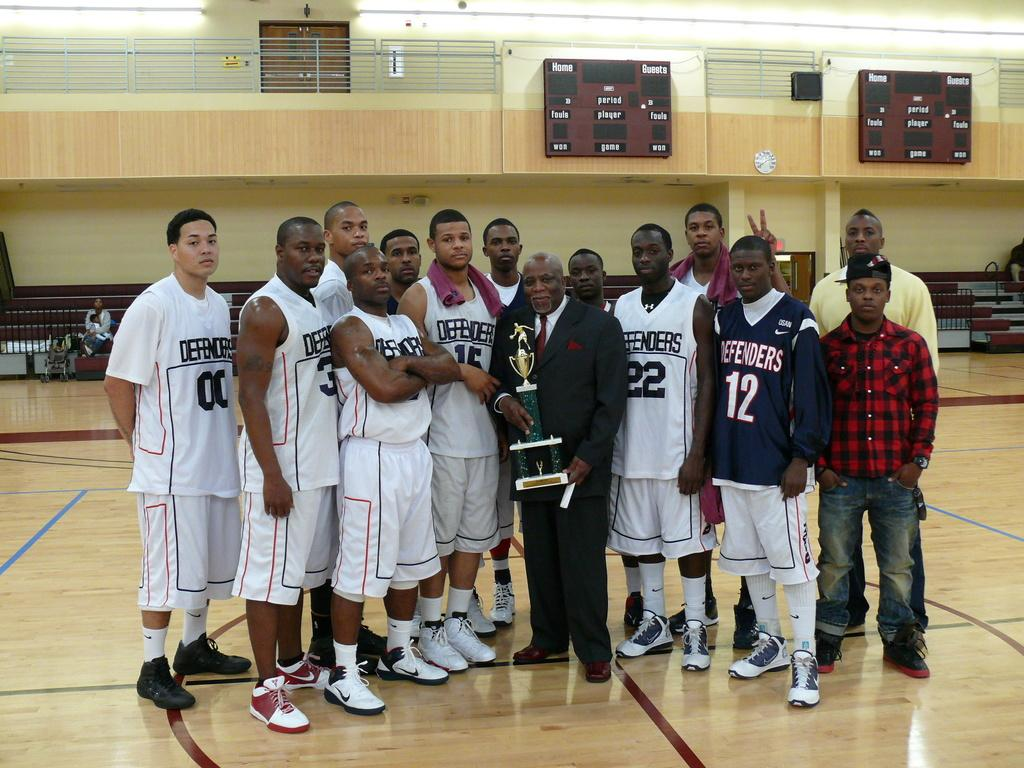What is the person in the foreground of the image holding? The person is holding a trophy in the foreground of the image. What can be seen in the center of the image? There are boys standing in the center of the image. What is visible in the background of the image? There are people, boards, a boundary, a door, and a light in the background of the image. What type of animals can be seen in the background of the image at the zoo? There is no zoo present in the image, and therefore no animals can be seen in the background. 